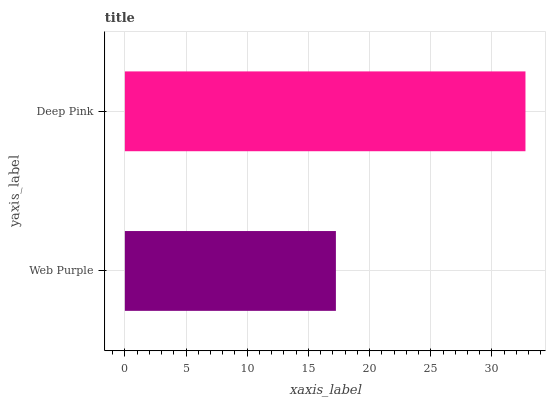Is Web Purple the minimum?
Answer yes or no. Yes. Is Deep Pink the maximum?
Answer yes or no. Yes. Is Deep Pink the minimum?
Answer yes or no. No. Is Deep Pink greater than Web Purple?
Answer yes or no. Yes. Is Web Purple less than Deep Pink?
Answer yes or no. Yes. Is Web Purple greater than Deep Pink?
Answer yes or no. No. Is Deep Pink less than Web Purple?
Answer yes or no. No. Is Deep Pink the high median?
Answer yes or no. Yes. Is Web Purple the low median?
Answer yes or no. Yes. Is Web Purple the high median?
Answer yes or no. No. Is Deep Pink the low median?
Answer yes or no. No. 